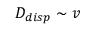<formula> <loc_0><loc_0><loc_500><loc_500>D _ { d i s p } \sim v</formula> 